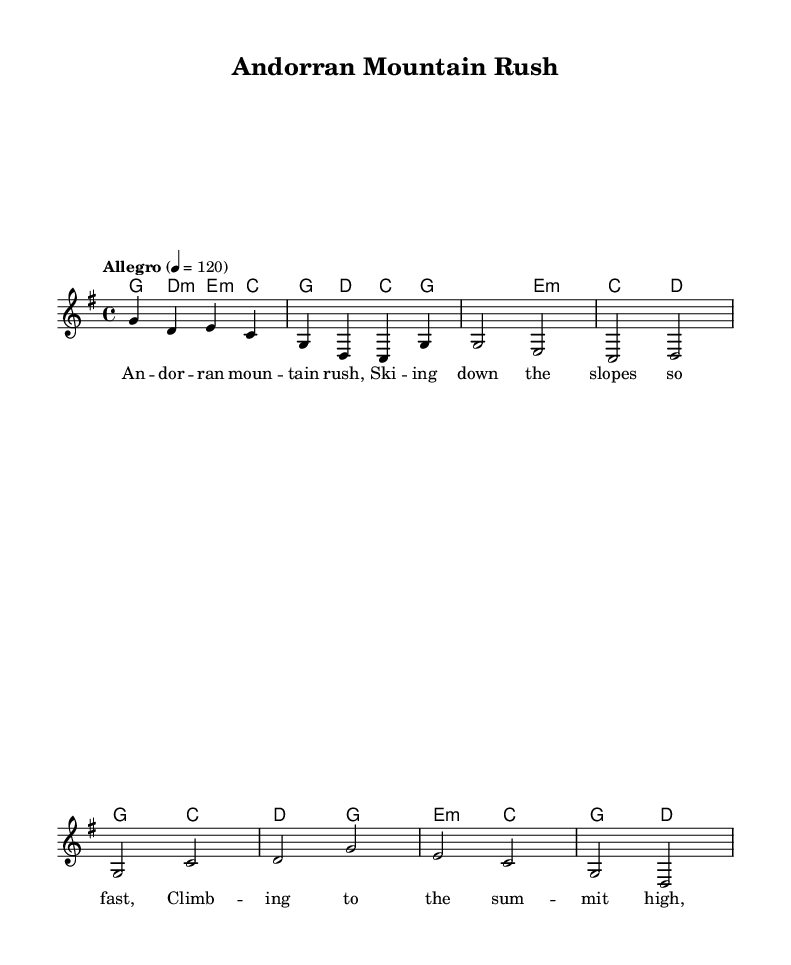What is the key signature of this music? The key signature is G major, indicated by one sharp (F#) at the beginning of the staff.
Answer: G major What is the time signature of the piece? The time signature is 4/4, shown as a fraction at the beginning of the score, which means there are four beats in each measure and the quarter note gets one beat.
Answer: 4/4 What is the tempo marking for this piece? The tempo marking is "Allegro," indicating a fast and lively pace, typically around 120 beats per minute.
Answer: Allegro How many measures are in the chorus section? The chorus consists of two measures, which can be counted in the score as the two lines labeled "Chorus."
Answer: 2 What type of musical texture is prominent in this song? This piece exhibits a homophonic texture, as the melody is supported by harmonic chords, allowing the main tune to stand out clearly.
Answer: Homophonic What sports theme is depicted in the lyrics? The lyrics mention skiing, which connects to Andorra's mountainous terrain and reflects the adventurous sports spirit typical of the region.
Answer: Skiing What traditional element does this music incorporate? The piece incorporates traditional Andorran melodies that are likely inspired by folk music from the region, blending with the country rock style.
Answer: Traditional Andorran melodies 